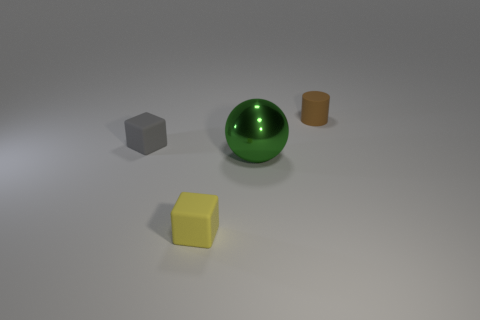Is the shape of the small matte thing in front of the big green thing the same as the gray rubber object? The small matte object does indeed share the same cubical shape as the gray object that appears to be made of rubber. Both objects have six faces, twelve edges, and eight vertices, which are characteristics of a cube. 